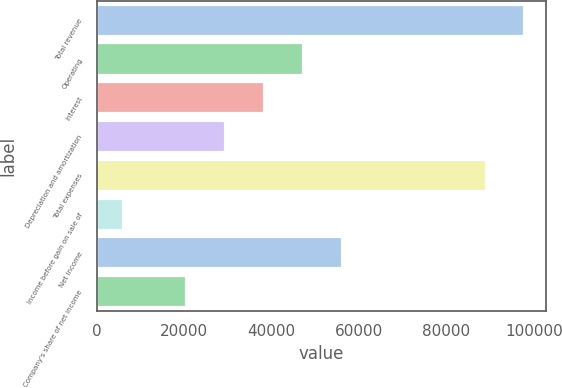Convert chart. <chart><loc_0><loc_0><loc_500><loc_500><bar_chart><fcel>Total revenue<fcel>Operating<fcel>Interest<fcel>Depreciation and amortization<fcel>Total expenses<fcel>Income before gain on sale of<fcel>Net income<fcel>Company's share of net income<nl><fcel>97857.1<fcel>47116.3<fcel>38220.2<fcel>29324.1<fcel>88961<fcel>6103<fcel>56012.4<fcel>20428<nl></chart> 